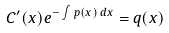<formula> <loc_0><loc_0><loc_500><loc_500>C ^ { \prime } ( x ) e ^ { - \int p ( x ) \, d x } = q ( x )</formula> 